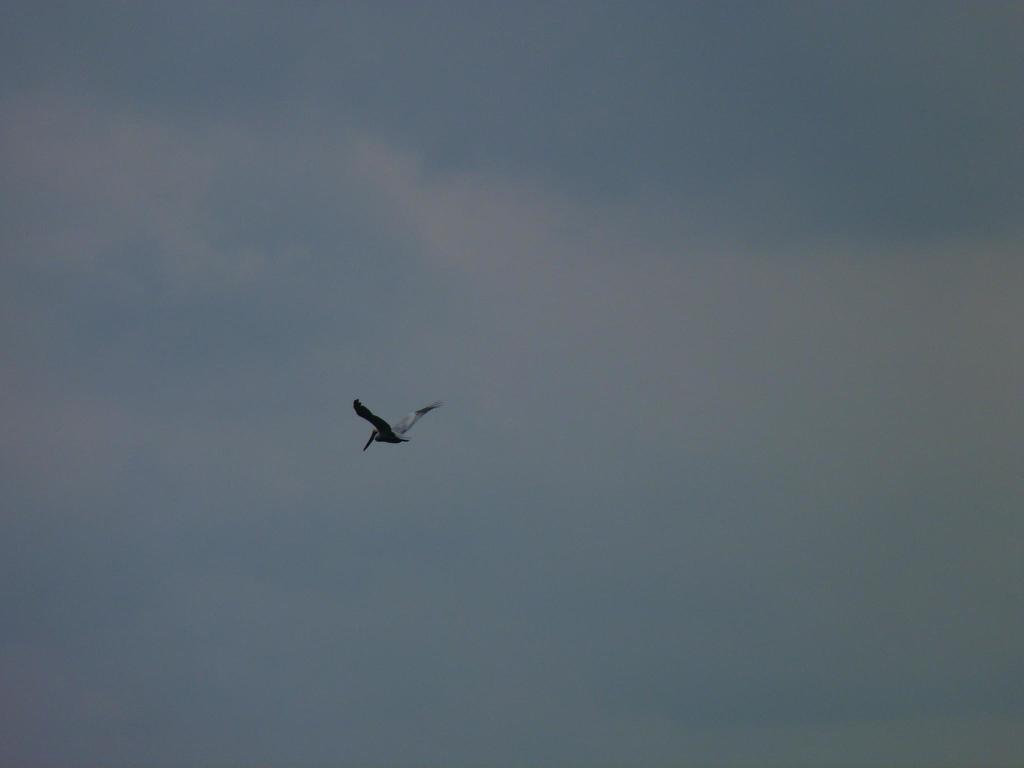Please provide a concise description of this image. In this picture we can see a bird flying in the air and in the background we can see the sky. 